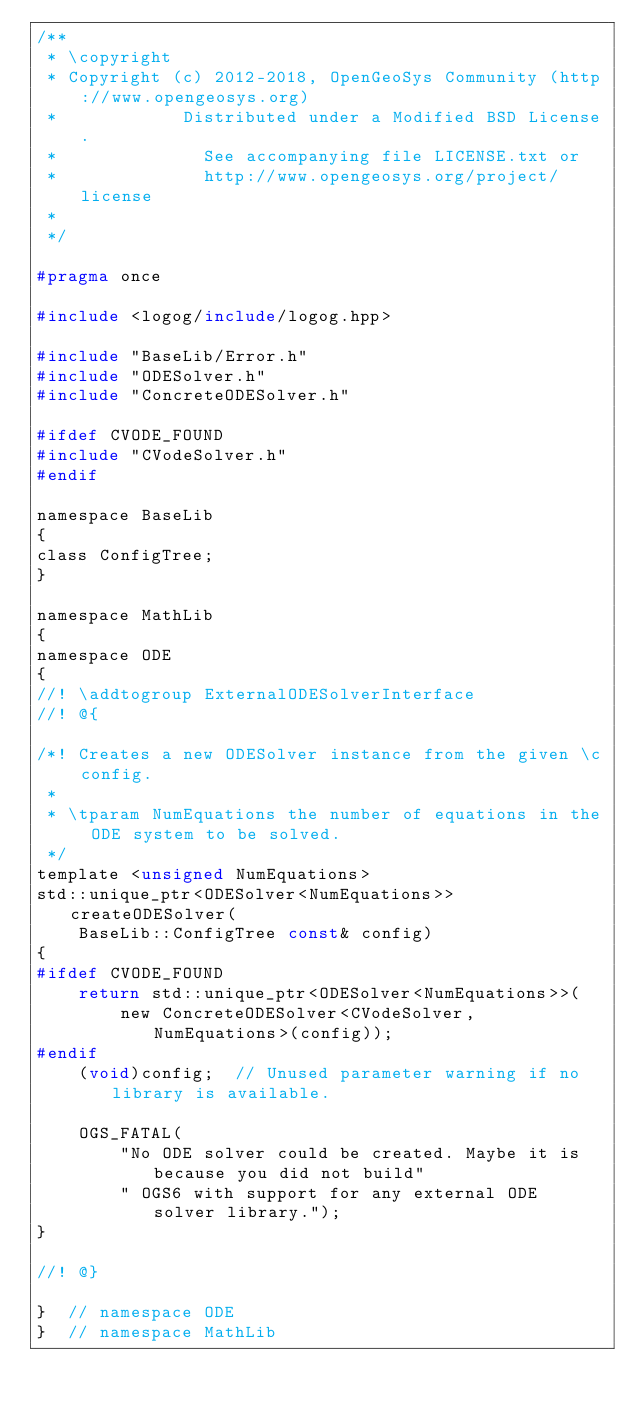Convert code to text. <code><loc_0><loc_0><loc_500><loc_500><_C_>/**
 * \copyright
 * Copyright (c) 2012-2018, OpenGeoSys Community (http://www.opengeosys.org)
 *            Distributed under a Modified BSD License.
 *              See accompanying file LICENSE.txt or
 *              http://www.opengeosys.org/project/license
 *
 */

#pragma once

#include <logog/include/logog.hpp>

#include "BaseLib/Error.h"
#include "ODESolver.h"
#include "ConcreteODESolver.h"

#ifdef CVODE_FOUND
#include "CVodeSolver.h"
#endif

namespace BaseLib
{
class ConfigTree;
}

namespace MathLib
{
namespace ODE
{
//! \addtogroup ExternalODESolverInterface
//! @{

/*! Creates a new ODESolver instance from the given \c config.
 *
 * \tparam NumEquations the number of equations in the ODE system to be solved.
 */
template <unsigned NumEquations>
std::unique_ptr<ODESolver<NumEquations>> createODESolver(
    BaseLib::ConfigTree const& config)
{
#ifdef CVODE_FOUND
    return std::unique_ptr<ODESolver<NumEquations>>(
        new ConcreteODESolver<CVodeSolver, NumEquations>(config));
#endif
    (void)config;  // Unused parameter warning if no library is available.

    OGS_FATAL(
        "No ODE solver could be created. Maybe it is because you did not build"
        " OGS6 with support for any external ODE solver library.");
}

//! @}

}  // namespace ODE
}  // namespace MathLib
</code> 